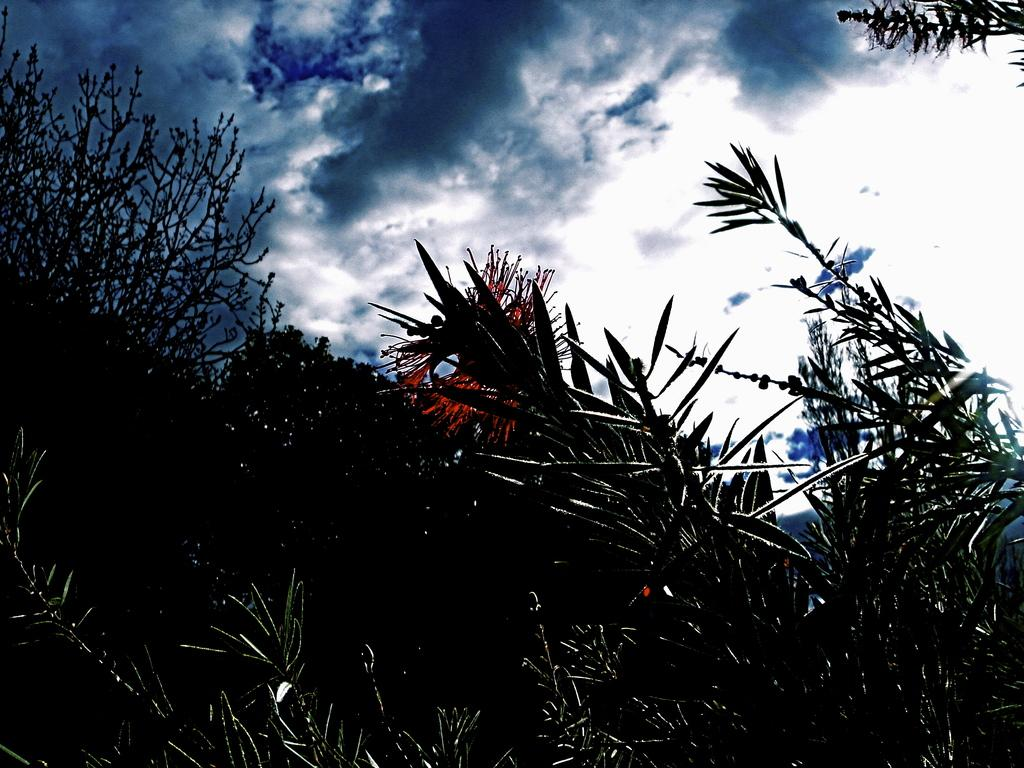What type of living organisms can be seen in the image? Plants and flowers are visible in the image. What color are the flowers in the image? The flowers in the image are red in color. What can be seen in the background of the image? There is a sky visible in the background of the image. What type of desk can be seen in the image? There is no desk present in the image. Can you describe the tiger's stripes in the image? There is no tiger present in the image, so it is not possible to describe its stripes. 